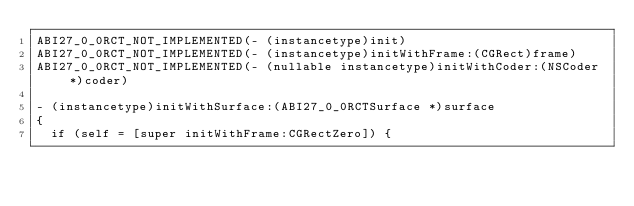Convert code to text. <code><loc_0><loc_0><loc_500><loc_500><_ObjectiveC_>ABI27_0_0RCT_NOT_IMPLEMENTED(- (instancetype)init)
ABI27_0_0RCT_NOT_IMPLEMENTED(- (instancetype)initWithFrame:(CGRect)frame)
ABI27_0_0RCT_NOT_IMPLEMENTED(- (nullable instancetype)initWithCoder:(NSCoder *)coder)

- (instancetype)initWithSurface:(ABI27_0_0RCTSurface *)surface
{
  if (self = [super initWithFrame:CGRectZero]) {</code> 